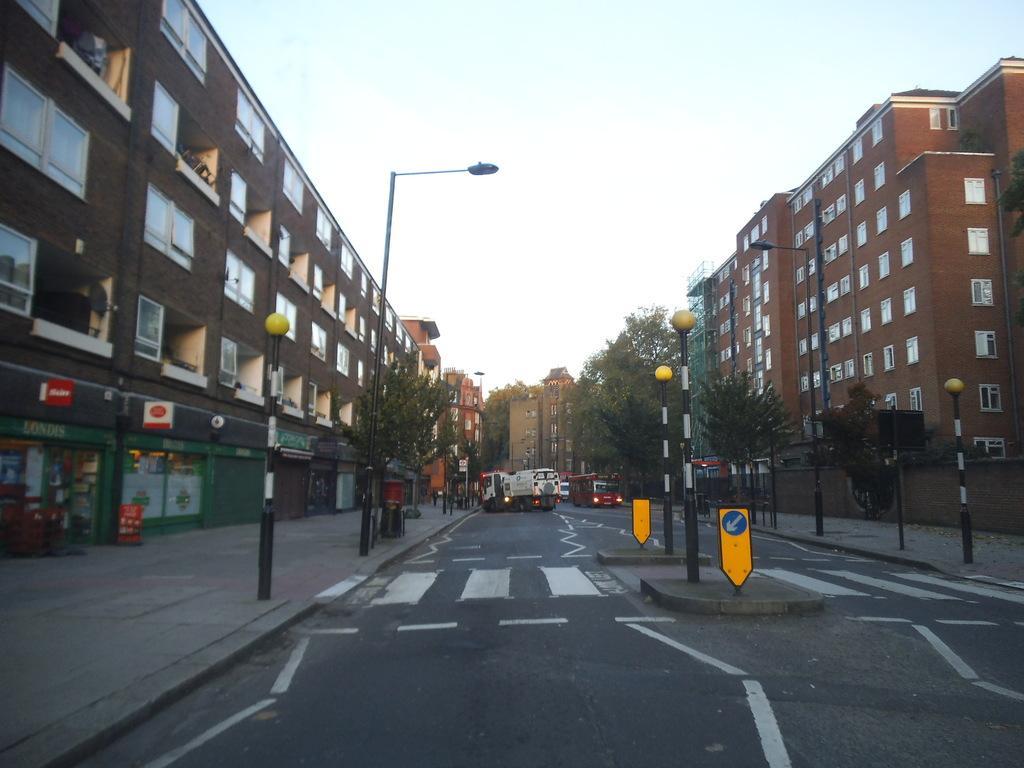In one or two sentences, can you explain what this image depicts? This picture is clicked outside. In the foreground we can see the concrete road and the zebra crossing and we can see the lamp posts and the poles. On both the sides we can see the sidewalks and the trees and the buildings. In the background we can see the sky, trees, buildings and the vehicles seems to be running on the road. On the left we can see a person like thing and we can see some other objects. On the left we can see the text on the boards which are attached to the building. 